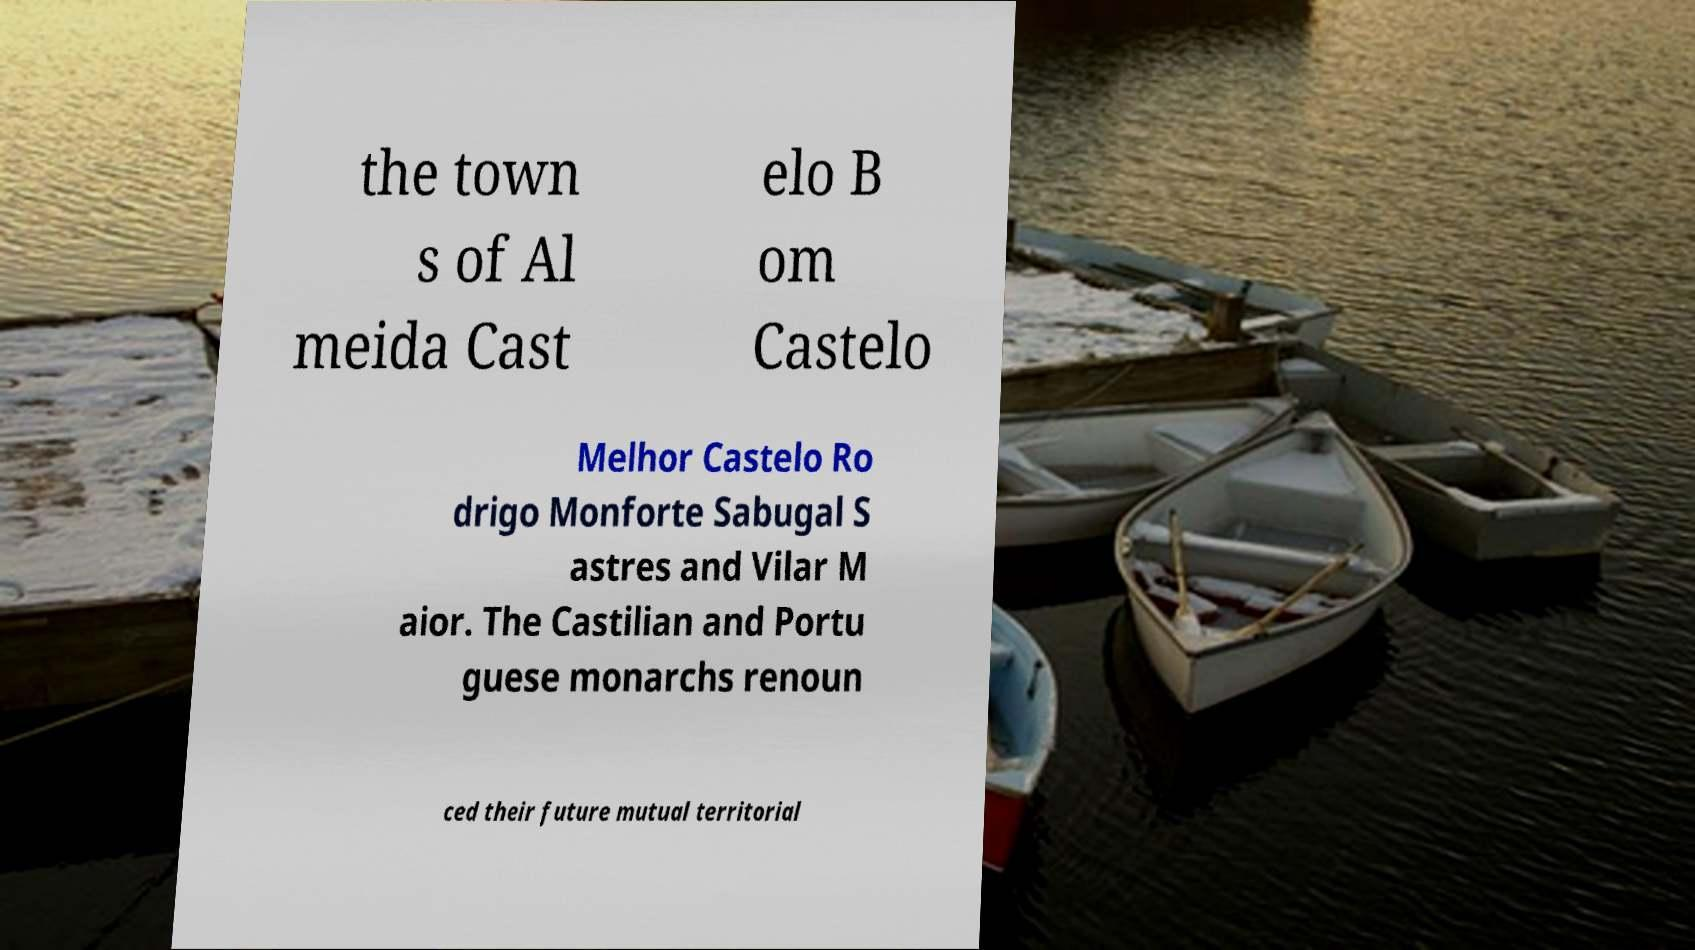Can you accurately transcribe the text from the provided image for me? the town s of Al meida Cast elo B om Castelo Melhor Castelo Ro drigo Monforte Sabugal S astres and Vilar M aior. The Castilian and Portu guese monarchs renoun ced their future mutual territorial 